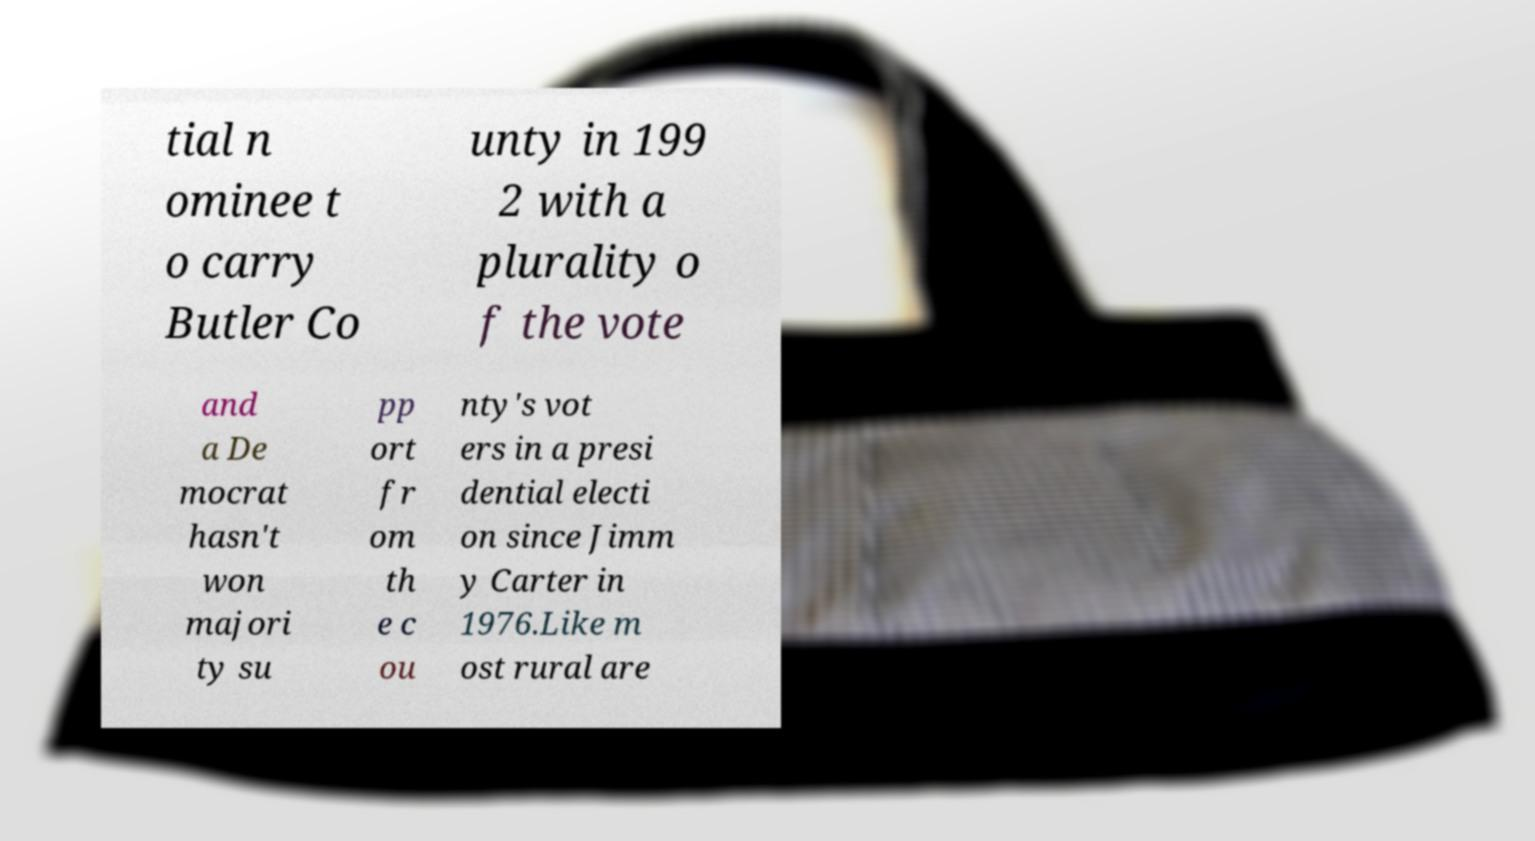I need the written content from this picture converted into text. Can you do that? tial n ominee t o carry Butler Co unty in 199 2 with a plurality o f the vote and a De mocrat hasn't won majori ty su pp ort fr om th e c ou nty's vot ers in a presi dential electi on since Jimm y Carter in 1976.Like m ost rural are 